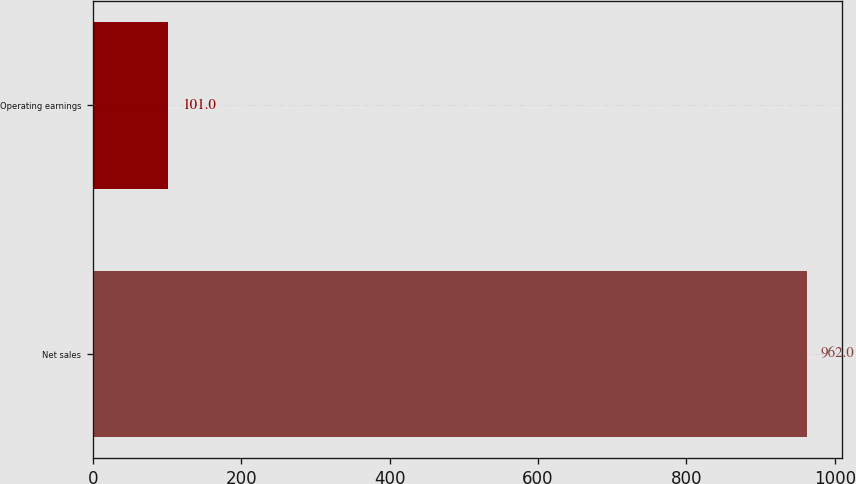Convert chart. <chart><loc_0><loc_0><loc_500><loc_500><bar_chart><fcel>Net sales<fcel>Operating earnings<nl><fcel>962<fcel>101<nl></chart> 